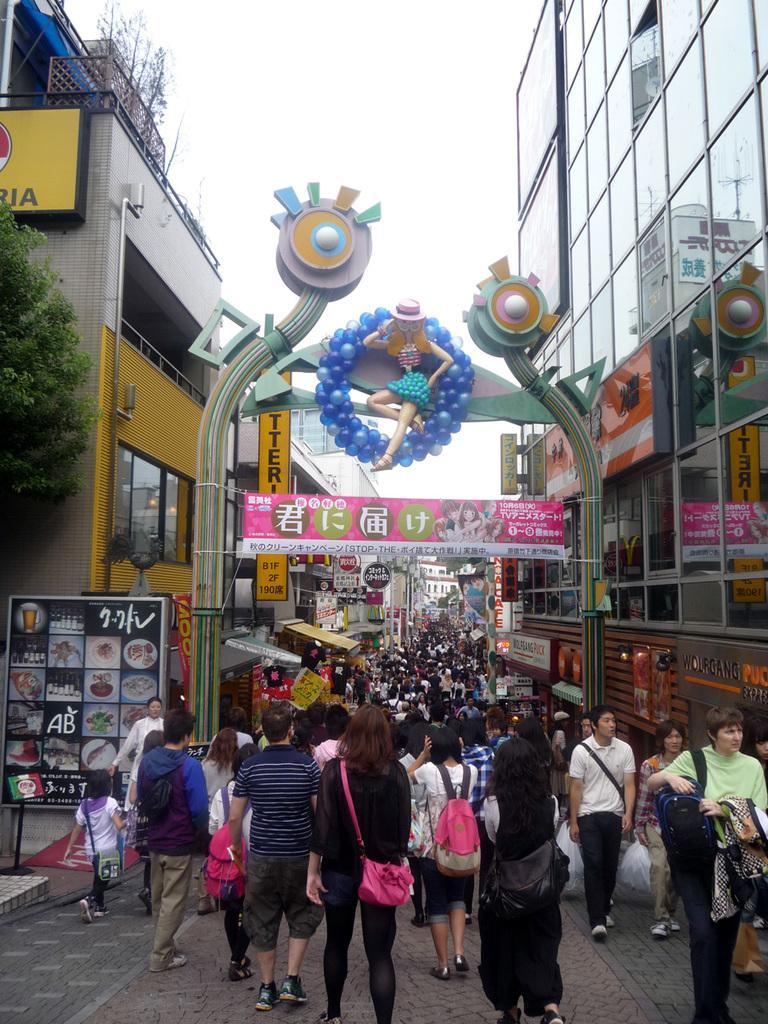Could you give a brief overview of what you see in this image? In this image it seems like a carnival. There is a road in the middle on which there are so many people walking on it. There are buildings on either side of the road. On the left side there is a hoarding on the footpath. Beside the hoarding there is a dustbin. On the left side there are few people walking on the road by holding the covers and bags. In the middle there is an arch. In the middle of the arch there is a girl sitting with the balloons around her. 